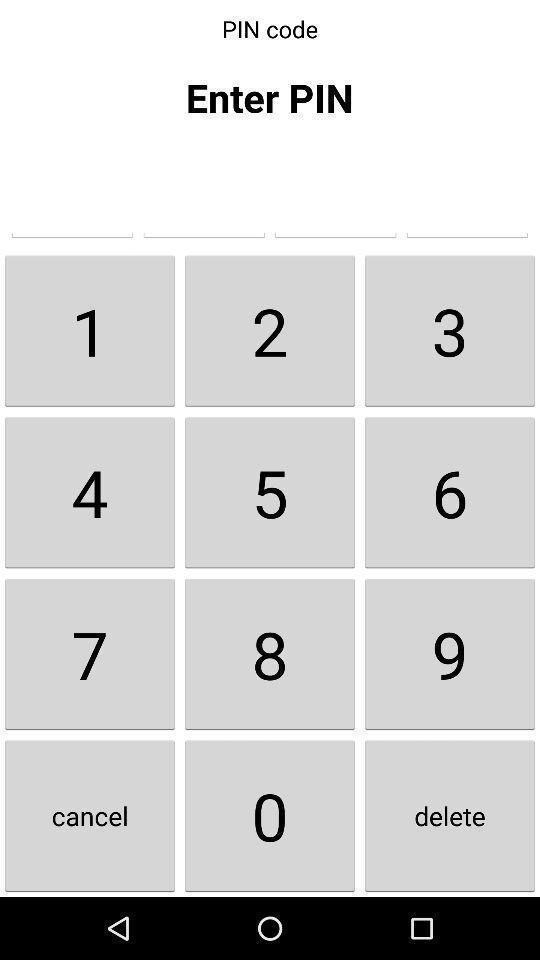Summarize the main components in this picture. Page showing different digits to enter pin code. 